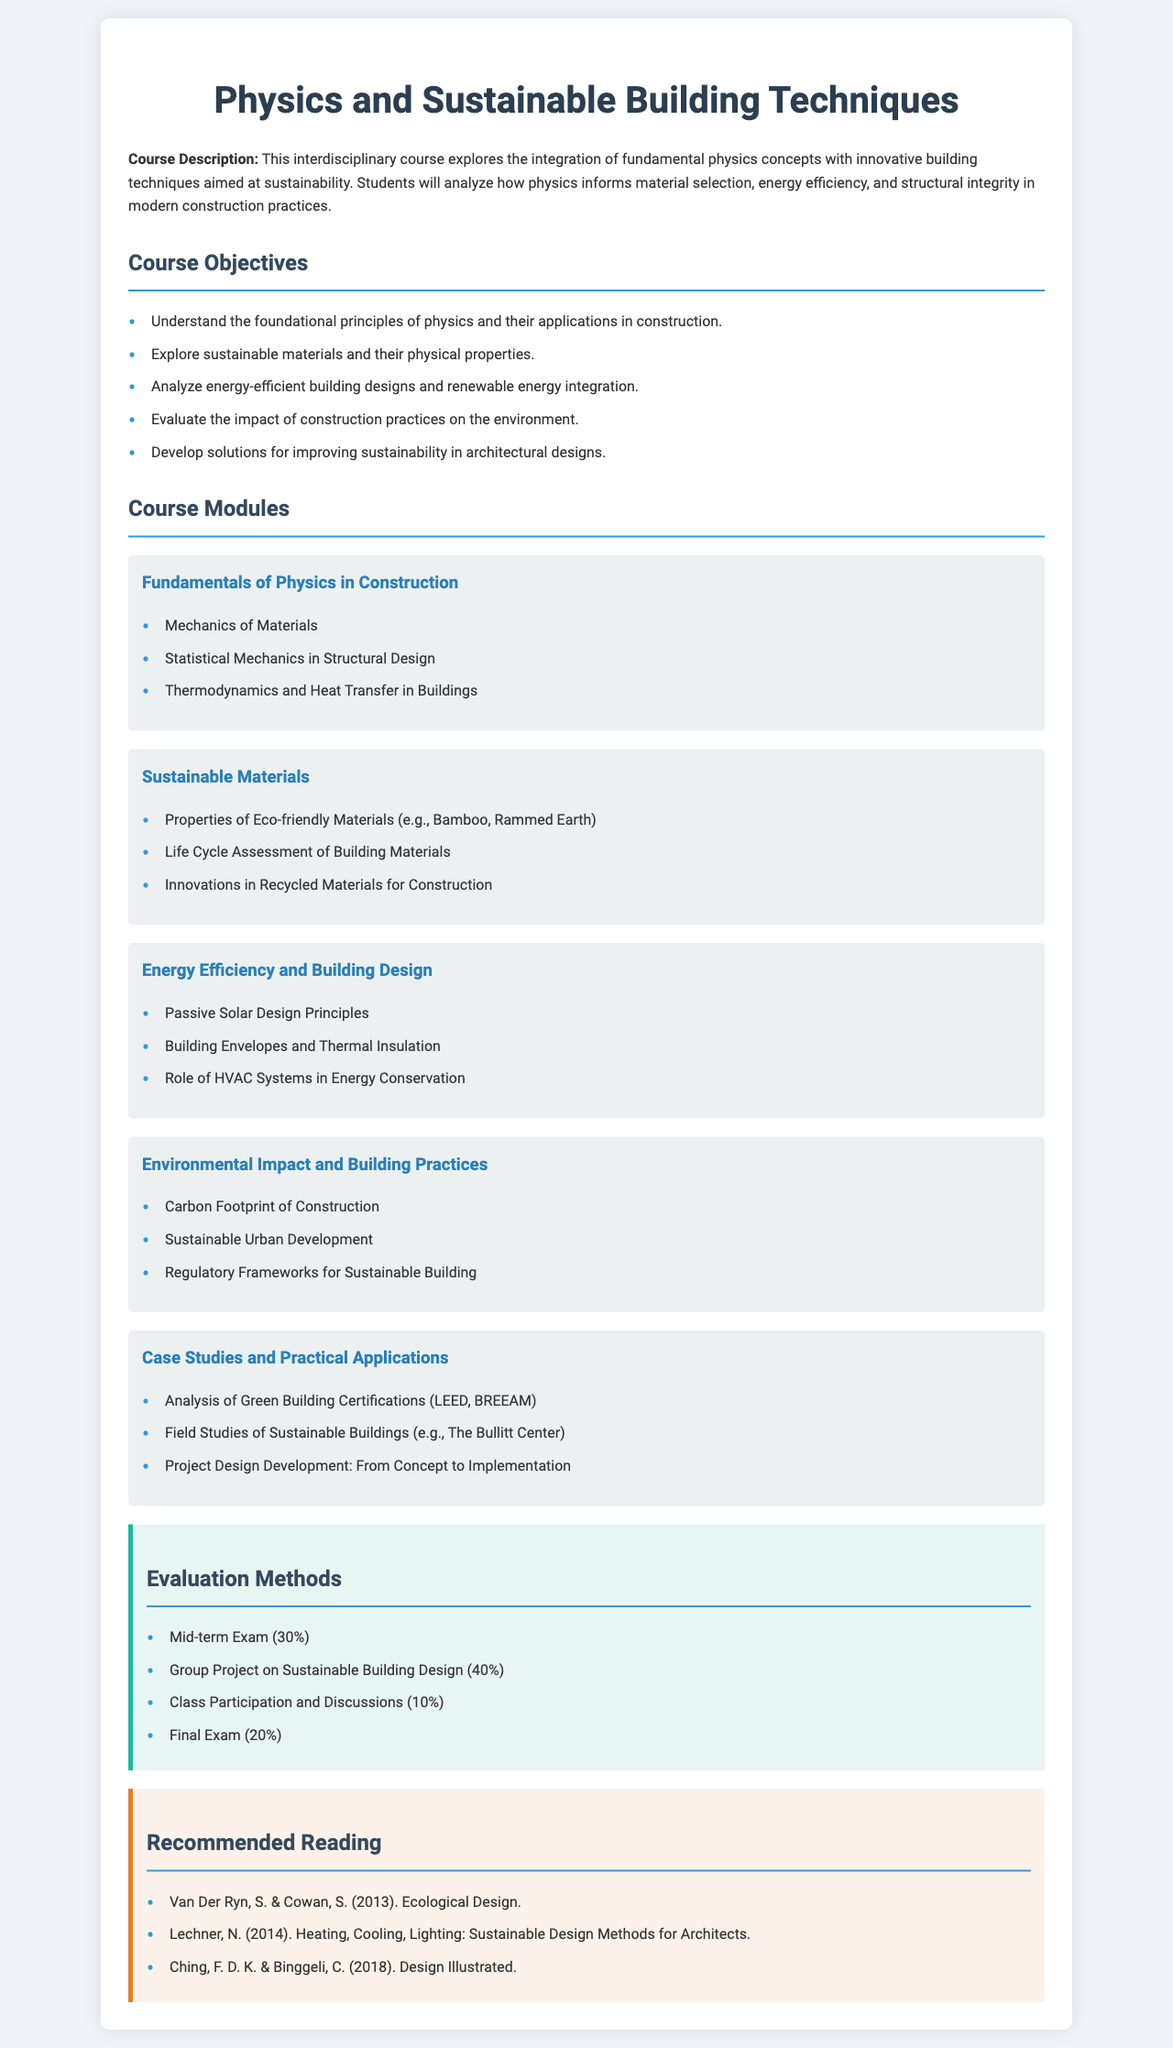What is the title of the course? The title of the course is prominently displayed at the top of the document, which is "Physics and Sustainable Building Techniques."
Answer: Physics and Sustainable Building Techniques What percentage of the evaluation is the Group Project responsible for? The evaluation section lists the Group Project on Sustainable Building Design and its weight, which is specified as 40%.
Answer: 40% Name one type of eco-friendly material discussed in the course. The module "Sustainable Materials" lists examples, including Bamboo and Rammed Earth, as eco-friendly materials.
Answer: Bamboo How many modules are part of the course? The course modules section outlines five distinct modules, so the total number is identified.
Answer: 5 What is the main focus of the course? The course description summarizes the main focus as the integration of fundamental physics concepts with innovative building techniques aimed at sustainability.
Answer: Sustainability What is one of the objectives of the course? The course objectives list several aims, such as understanding the foundational principles of physics and their applications in construction.
Answer: Understand the foundational principles of physics Which reading focuses on sustainable design methods for architects? The recommended reading section mentions "Heating, Cooling, Lighting: Sustainable Design Methods for Architects" as relevant to the course.
Answer: Heating, Cooling, Lighting: Sustainable Design Methods for Architects What is the last module listed in the course outline? The modules are presented in a specific order, with "Case Studies and Practical Applications" being the last one mentioned.
Answer: Case Studies and Practical Applications What is the weight of Class Participation and Discussions in the evaluation? The evaluation section specifies the proportion of Class Participation and Discussions, which is listed as 10%.
Answer: 10% 